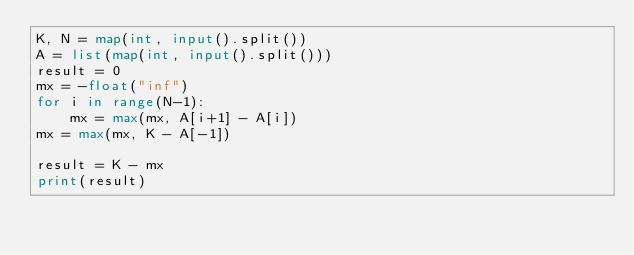<code> <loc_0><loc_0><loc_500><loc_500><_Python_>K, N = map(int, input().split())
A = list(map(int, input().split()))
result = 0
mx = -float("inf")
for i in range(N-1):
    mx = max(mx, A[i+1] - A[i])
mx = max(mx, K - A[-1])

result = K - mx
print(result)</code> 